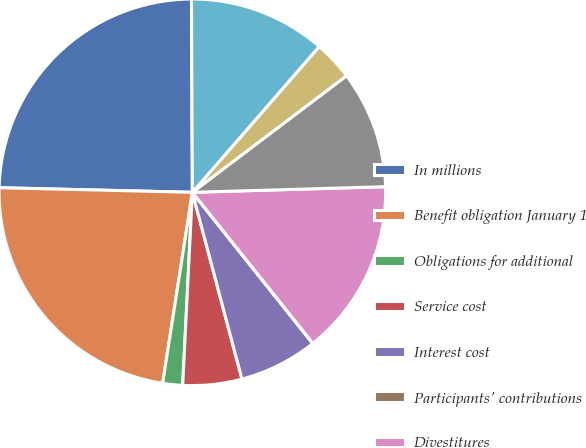Convert chart to OTSL. <chart><loc_0><loc_0><loc_500><loc_500><pie_chart><fcel>In millions<fcel>Benefit obligation January 1<fcel>Obligations for additional<fcel>Service cost<fcel>Interest cost<fcel>Participants' contributions<fcel>Divestitures<fcel>Actuarial (gain) loss<fcel>Benefits paid<fcel>Effect of foreign currency<nl><fcel>24.55%<fcel>22.92%<fcel>1.66%<fcel>4.93%<fcel>6.57%<fcel>0.02%<fcel>14.74%<fcel>9.84%<fcel>3.3%<fcel>11.47%<nl></chart> 